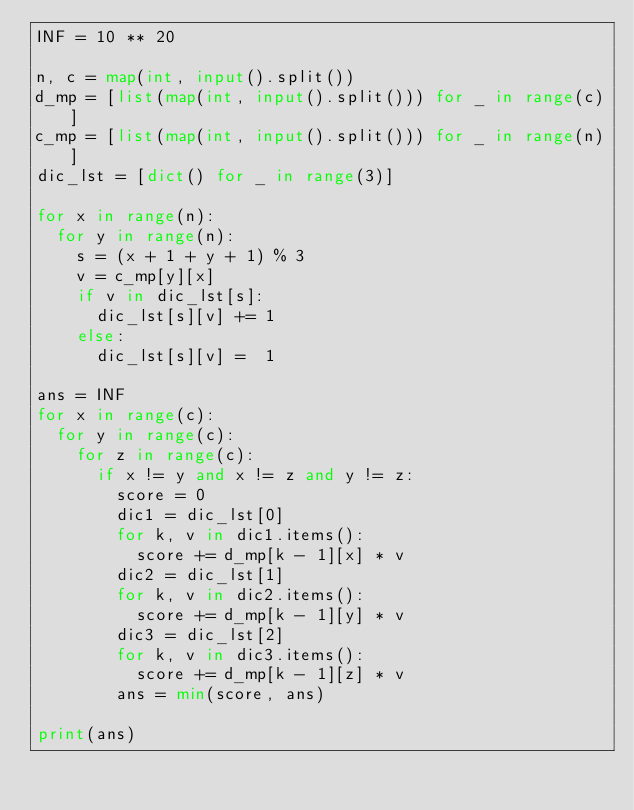<code> <loc_0><loc_0><loc_500><loc_500><_Python_>INF = 10 ** 20

n, c = map(int, input().split())
d_mp = [list(map(int, input().split())) for _ in range(c)]
c_mp = [list(map(int, input().split())) for _ in range(n)]
dic_lst = [dict() for _ in range(3)]

for x in range(n):
  for y in range(n):
    s = (x + 1 + y + 1) % 3
    v = c_mp[y][x]
    if v in dic_lst[s]:
      dic_lst[s][v] += 1
    else:
      dic_lst[s][v] =  1

ans = INF
for x in range(c):
  for y in range(c):
    for z in range(c):
      if x != y and x != z and y != z:
        score = 0
        dic1 = dic_lst[0]
        for k, v in dic1.items():
          score += d_mp[k - 1][x] * v
        dic2 = dic_lst[1]
        for k, v in dic2.items():
          score += d_mp[k - 1][y] * v
        dic3 = dic_lst[2]
        for k, v in dic3.items():
          score += d_mp[k - 1][z] * v
        ans = min(score, ans)

print(ans)</code> 